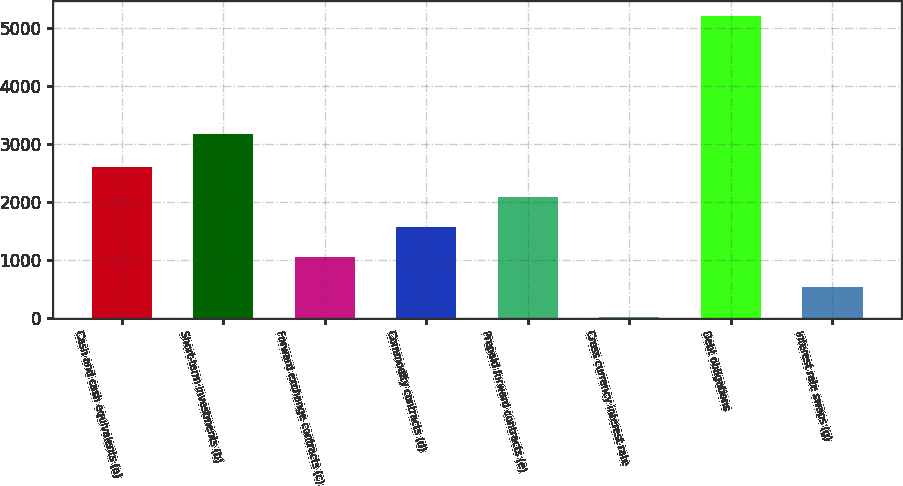Convert chart. <chart><loc_0><loc_0><loc_500><loc_500><bar_chart><fcel>Cash and cash equivalents (a)<fcel>Short-term investments (b)<fcel>Forward exchange contracts (c)<fcel>Commodity contracts (d)<fcel>Prepaid forward contracts (e)<fcel>Cross currency interest rate<fcel>Debt obligations<fcel>Interest rate swaps (g)<nl><fcel>2604<fcel>3166<fcel>1045.2<fcel>1564.8<fcel>2084.4<fcel>6<fcel>5202<fcel>525.6<nl></chart> 